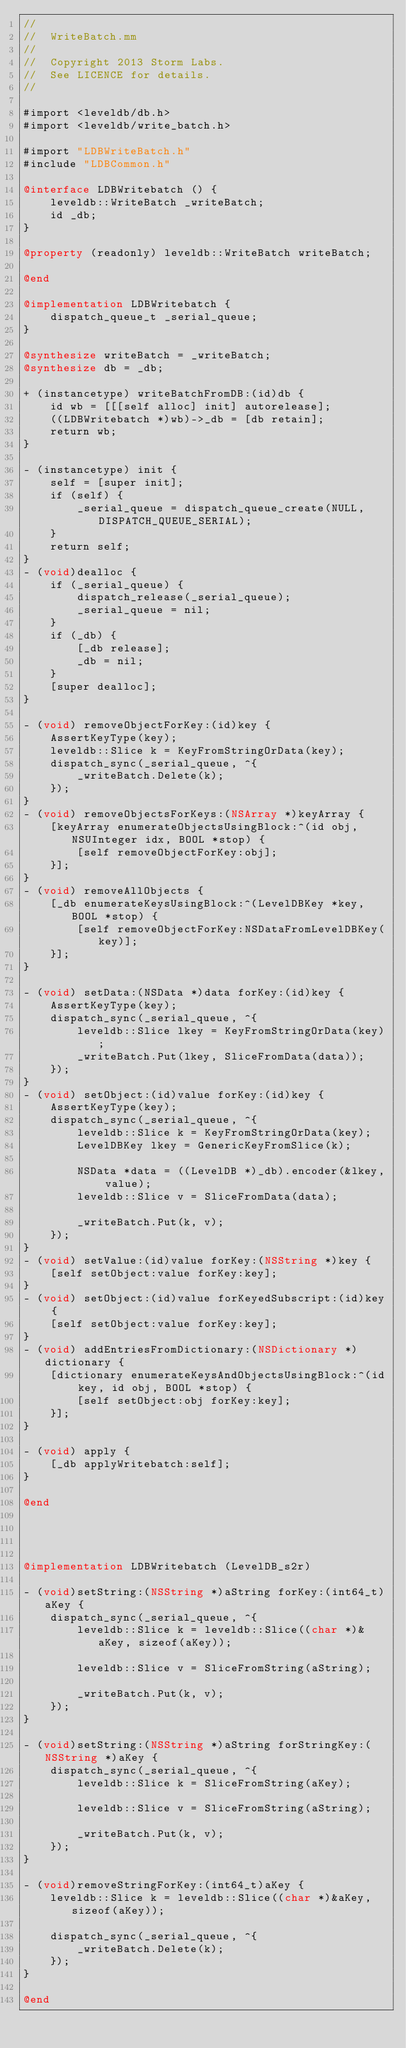<code> <loc_0><loc_0><loc_500><loc_500><_ObjectiveC_>//
//  WriteBatch.mm
//
//  Copyright 2013 Storm Labs. 
//  See LICENCE for details.
//

#import <leveldb/db.h>
#import <leveldb/write_batch.h>

#import "LDBWriteBatch.h"
#include "LDBCommon.h"

@interface LDBWritebatch () {
    leveldb::WriteBatch _writeBatch;
    id _db;
}

@property (readonly) leveldb::WriteBatch writeBatch;

@end

@implementation LDBWritebatch {
    dispatch_queue_t _serial_queue;
}

@synthesize writeBatch = _writeBatch;
@synthesize db = _db;

+ (instancetype) writeBatchFromDB:(id)db {
    id wb = [[[self alloc] init] autorelease];
    ((LDBWritebatch *)wb)->_db = [db retain];
    return wb;
}

- (instancetype) init {
    self = [super init];
    if (self) {
        _serial_queue = dispatch_queue_create(NULL, DISPATCH_QUEUE_SERIAL);
    }
    return self;
}
- (void)dealloc {
    if (_serial_queue) {
        dispatch_release(_serial_queue);
        _serial_queue = nil;
    }
    if (_db) {
        [_db release];
        _db = nil;
    }
    [super dealloc];
}

- (void) removeObjectForKey:(id)key {
    AssertKeyType(key);
    leveldb::Slice k = KeyFromStringOrData(key);
    dispatch_sync(_serial_queue, ^{
        _writeBatch.Delete(k);
    });
}
- (void) removeObjectsForKeys:(NSArray *)keyArray {
    [keyArray enumerateObjectsUsingBlock:^(id obj, NSUInteger idx, BOOL *stop) {
        [self removeObjectForKey:obj];
    }];
}
- (void) removeAllObjects {
    [_db enumerateKeysUsingBlock:^(LevelDBKey *key, BOOL *stop) {
        [self removeObjectForKey:NSDataFromLevelDBKey(key)];
    }];
}

- (void) setData:(NSData *)data forKey:(id)key {
    AssertKeyType(key);
    dispatch_sync(_serial_queue, ^{
        leveldb::Slice lkey = KeyFromStringOrData(key);
        _writeBatch.Put(lkey, SliceFromData(data));
    });
}
- (void) setObject:(id)value forKey:(id)key {
    AssertKeyType(key);
    dispatch_sync(_serial_queue, ^{
        leveldb::Slice k = KeyFromStringOrData(key);
        LevelDBKey lkey = GenericKeyFromSlice(k);
        
        NSData *data = ((LevelDB *)_db).encoder(&lkey, value);
        leveldb::Slice v = SliceFromData(data);
        
        _writeBatch.Put(k, v);
    });
}
- (void) setValue:(id)value forKey:(NSString *)key {
    [self setObject:value forKey:key];
}
- (void) setObject:(id)value forKeyedSubscript:(id)key {
    [self setObject:value forKey:key];
}
- (void) addEntriesFromDictionary:(NSDictionary *)dictionary {
    [dictionary enumerateKeysAndObjectsUsingBlock:^(id key, id obj, BOOL *stop) {
        [self setObject:obj forKey:key];
    }];
}

- (void) apply {
    [_db applyWritebatch:self];
}

@end




@implementation LDBWritebatch (LevelDB_s2r)

- (void)setString:(NSString *)aString forKey:(int64_t)aKey {
    dispatch_sync(_serial_queue, ^{
        leveldb::Slice k = leveldb::Slice((char *)&aKey, sizeof(aKey));
        
        leveldb::Slice v = SliceFromString(aString);
         
        _writeBatch.Put(k, v);
    });
}

- (void)setString:(NSString *)aString forStringKey:(NSString *)aKey {
    dispatch_sync(_serial_queue, ^{
        leveldb::Slice k = SliceFromString(aKey);
        
        leveldb::Slice v = SliceFromString(aString);
         
        _writeBatch.Put(k, v);
    });
}

- (void)removeStringForKey:(int64_t)aKey {
    leveldb::Slice k = leveldb::Slice((char *)&aKey, sizeof(aKey));
    
    dispatch_sync(_serial_queue, ^{
        _writeBatch.Delete(k);
    });
}

@end
</code> 